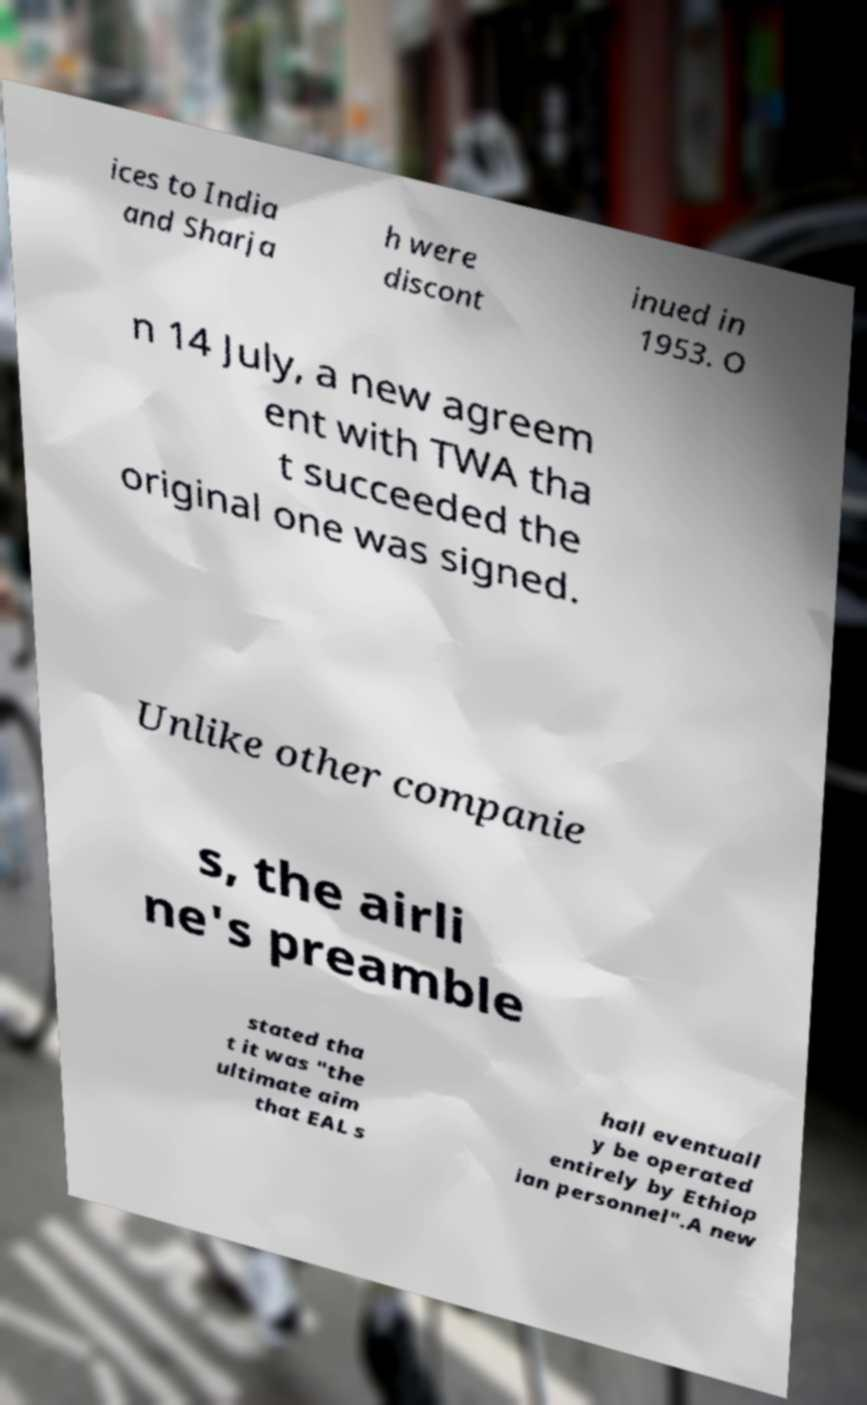Could you extract and type out the text from this image? ices to India and Sharja h were discont inued in 1953. O n 14 July, a new agreem ent with TWA tha t succeeded the original one was signed. Unlike other companie s, the airli ne's preamble stated tha t it was "the ultimate aim that EAL s hall eventuall y be operated entirely by Ethiop ian personnel".A new 